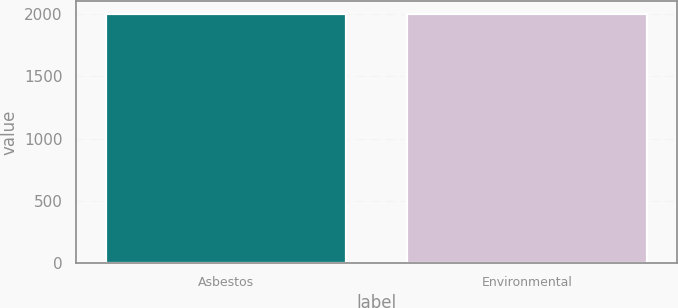Convert chart. <chart><loc_0><loc_0><loc_500><loc_500><bar_chart><fcel>Asbestos<fcel>Environmental<nl><fcel>2005<fcel>2005.1<nl></chart> 